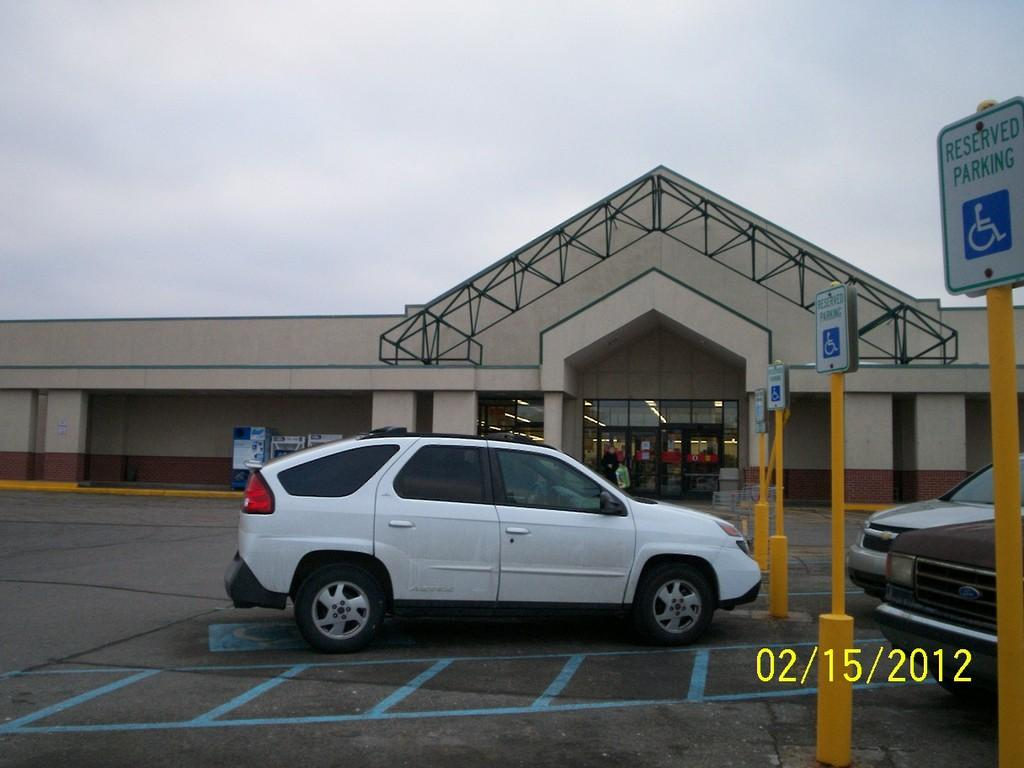What type of structure is visible in the image? There is a building in the image. What is located in front of the building? There is a car in front of the building. What else can be seen in the image besides the building and car? There are poles with boards in the image. What type of blade is being used to sort the items in the image? There is no blade or sorting activity present in the image. 